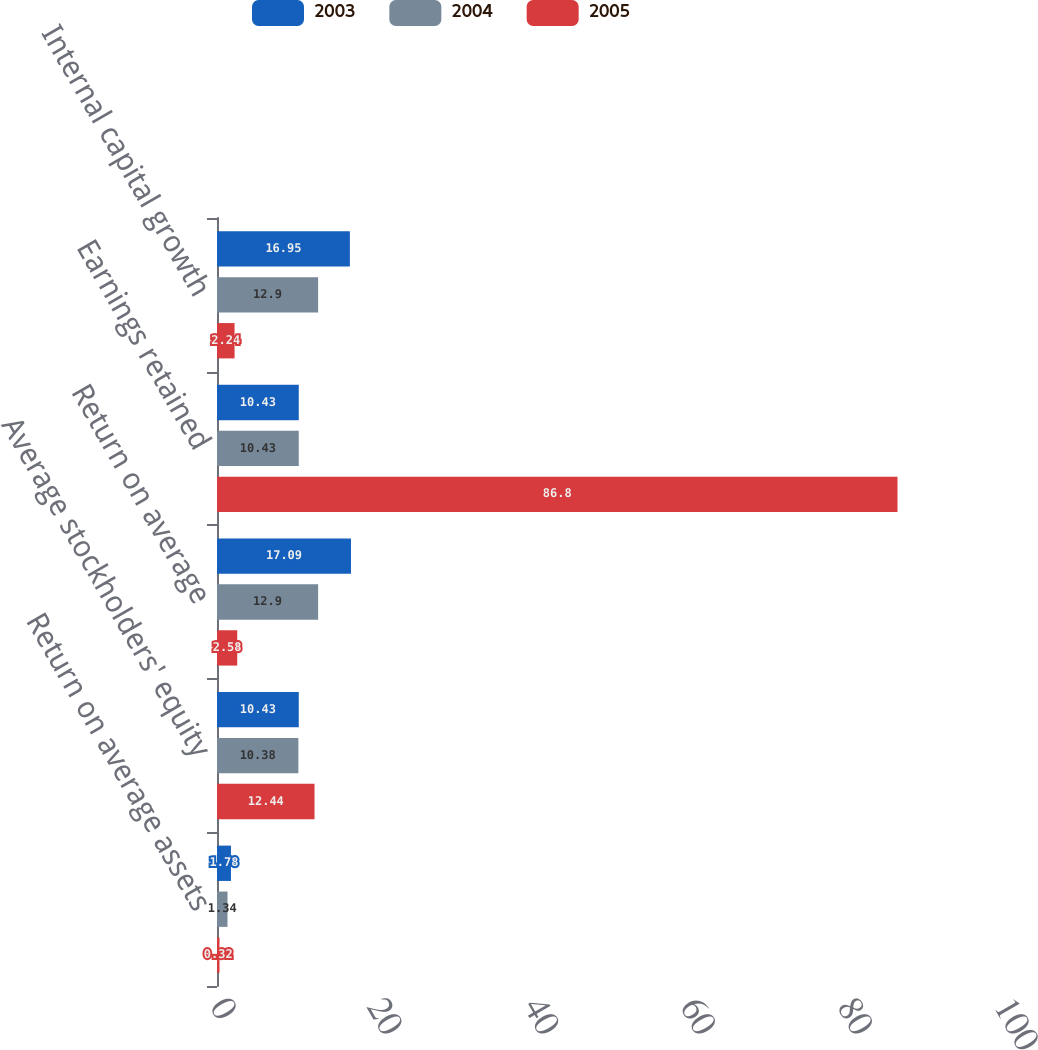Convert chart to OTSL. <chart><loc_0><loc_0><loc_500><loc_500><stacked_bar_chart><ecel><fcel>Return on average assets<fcel>Average stockholders' equity<fcel>Return on average<fcel>Earnings retained<fcel>Internal capital growth<nl><fcel>2003<fcel>1.78<fcel>10.43<fcel>17.09<fcel>10.43<fcel>16.95<nl><fcel>2004<fcel>1.34<fcel>10.38<fcel>12.9<fcel>10.43<fcel>12.9<nl><fcel>2005<fcel>0.32<fcel>12.44<fcel>2.58<fcel>86.8<fcel>2.24<nl></chart> 